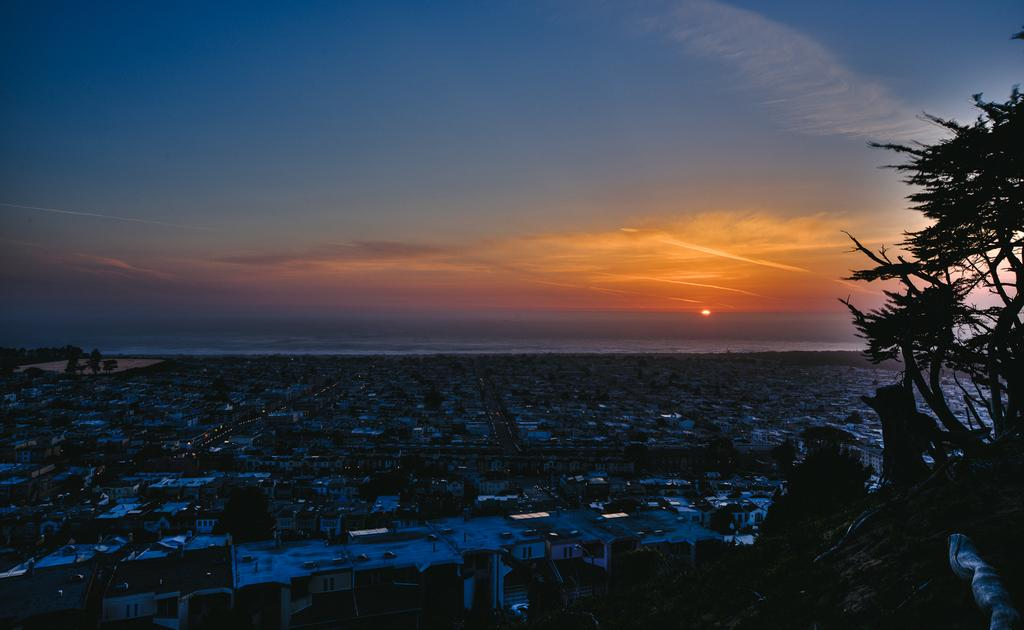What type of view is shown in the image? The image is an aerial view of a city. What types of structures can be seen in the image? There are houses in the image. What other natural elements are present in the image? There are trees in the image. What celestial body is visible in the image? The sun is visible in the image. What else can be seen in the sky in the image? The sky is visible in the image. What type of rod can be seen holding up the trees in the image? There is no rod holding up the trees in the image; the trees are standing on their own. What type of songs can be heard playing in the background of the image? There is no audio in the image, so it is not possible to determine what songs might be heard. 